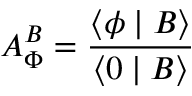Convert formula to latex. <formula><loc_0><loc_0><loc_500><loc_500>A _ { \Phi } ^ { B } = \frac { \langle \phi | B \rangle } { \langle 0 | B \rangle }</formula> 